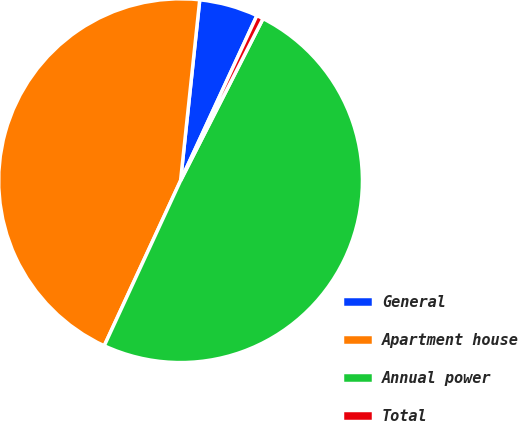<chart> <loc_0><loc_0><loc_500><loc_500><pie_chart><fcel>General<fcel>Apartment house<fcel>Annual power<fcel>Total<nl><fcel>5.21%<fcel>44.79%<fcel>49.4%<fcel>0.6%<nl></chart> 